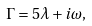<formula> <loc_0><loc_0><loc_500><loc_500>\Gamma = 5 \lambda + i \omega ,</formula> 